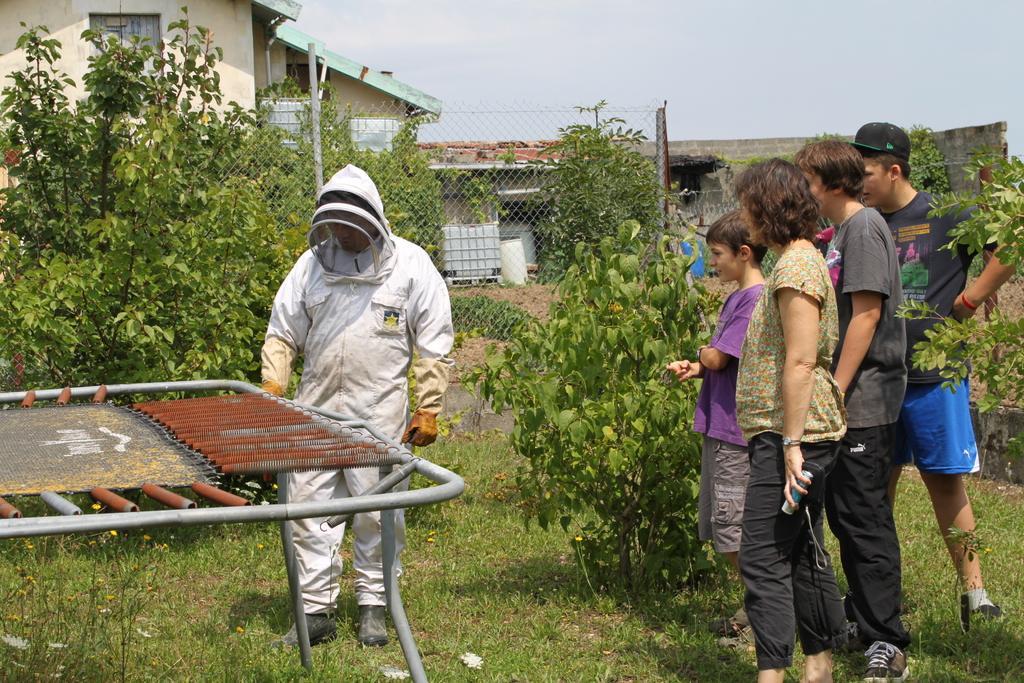Can you describe this image briefly? There are group of people standing. These are the trees. I can see a fence. This is an object placed on the ground. I can see the plants and the grass. Here is the other person standing. These are the houses and a building. 